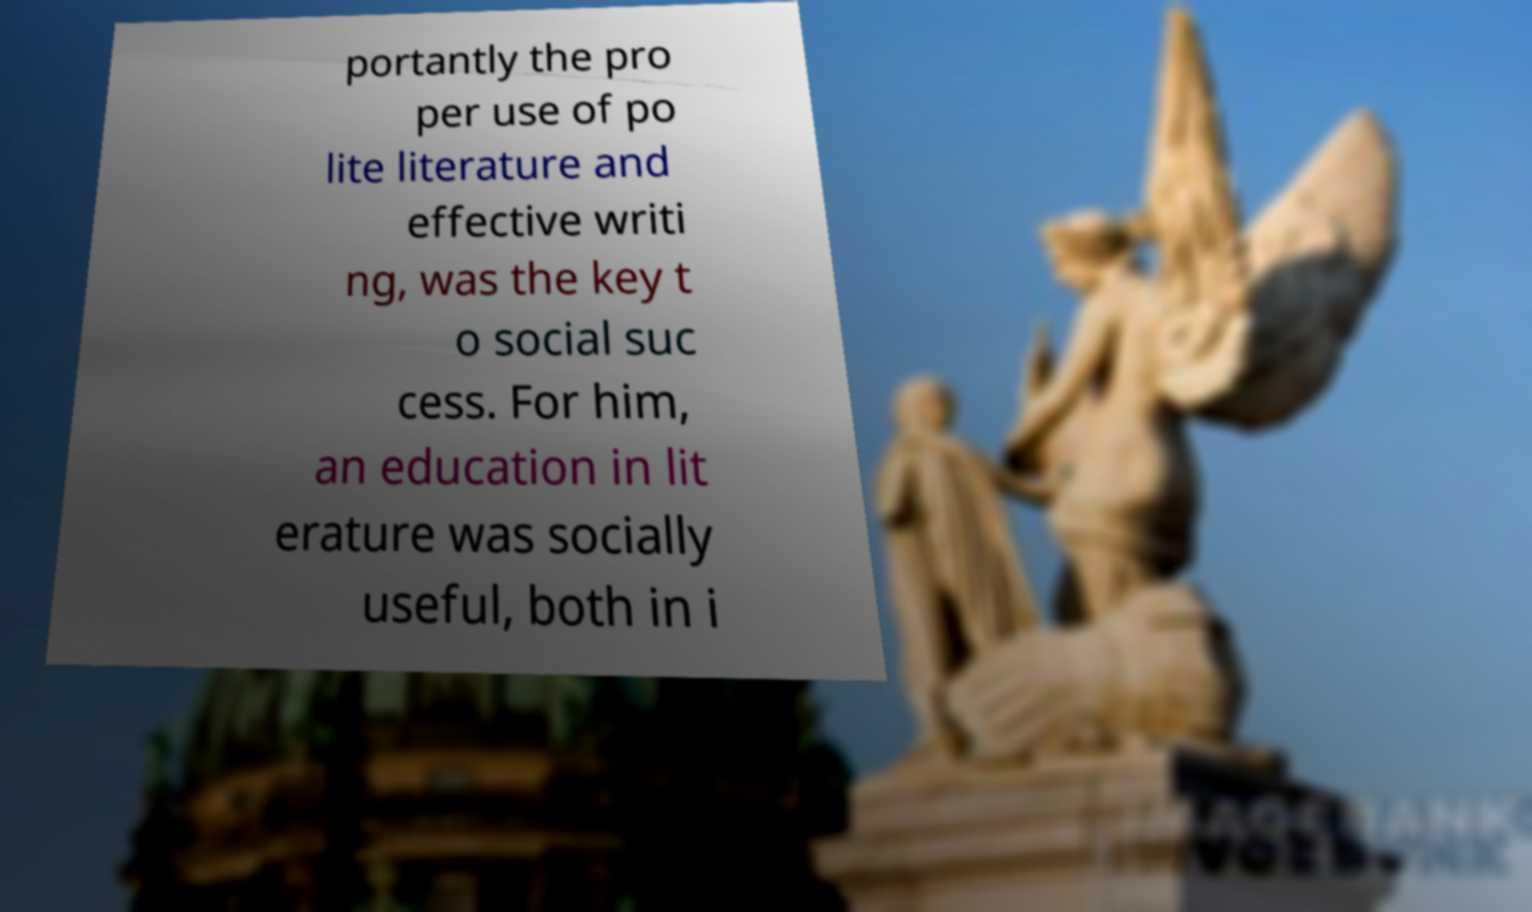Could you assist in decoding the text presented in this image and type it out clearly? portantly the pro per use of po lite literature and effective writi ng, was the key t o social suc cess. For him, an education in lit erature was socially useful, both in i 